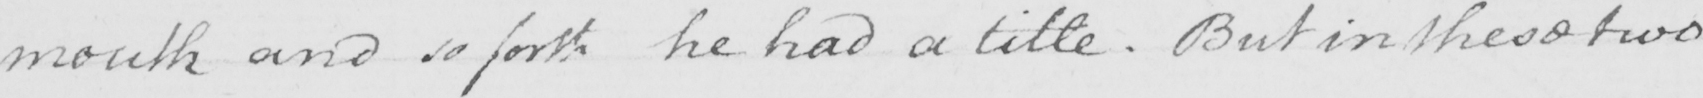Transcribe the text shown in this historical manuscript line. mouth and so forth he had a title . But in these two 